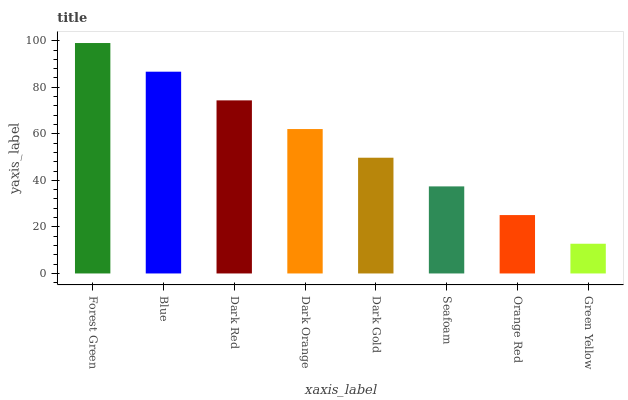Is Green Yellow the minimum?
Answer yes or no. Yes. Is Forest Green the maximum?
Answer yes or no. Yes. Is Blue the minimum?
Answer yes or no. No. Is Blue the maximum?
Answer yes or no. No. Is Forest Green greater than Blue?
Answer yes or no. Yes. Is Blue less than Forest Green?
Answer yes or no. Yes. Is Blue greater than Forest Green?
Answer yes or no. No. Is Forest Green less than Blue?
Answer yes or no. No. Is Dark Orange the high median?
Answer yes or no. Yes. Is Dark Gold the low median?
Answer yes or no. Yes. Is Seafoam the high median?
Answer yes or no. No. Is Blue the low median?
Answer yes or no. No. 